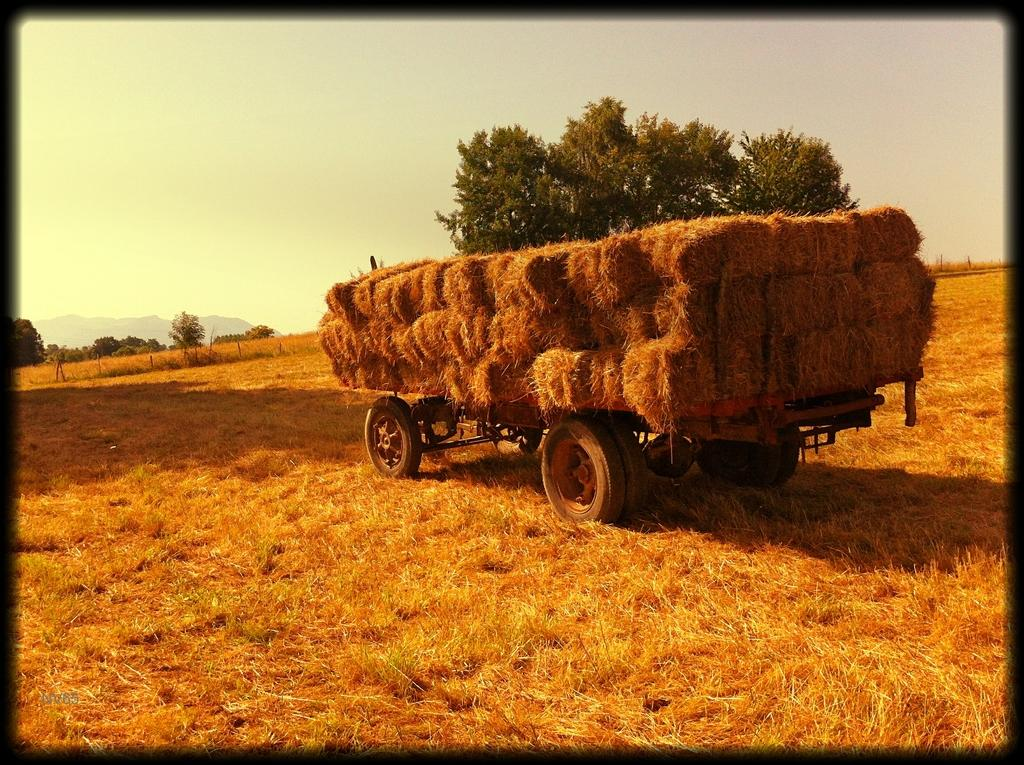What is the vehicle in the image filled with? The vehicle is filled with dry leaves. Are there any dry leaves visible outside the vehicle? Yes, dry leaves are visible around the vehicle. What type of natural elements can be seen in the image? There are trees in the image. What type of soup can be seen simmering in the image? There is no soup present in the image; it features a vehicle filled with dry leaves and trees in the background. 